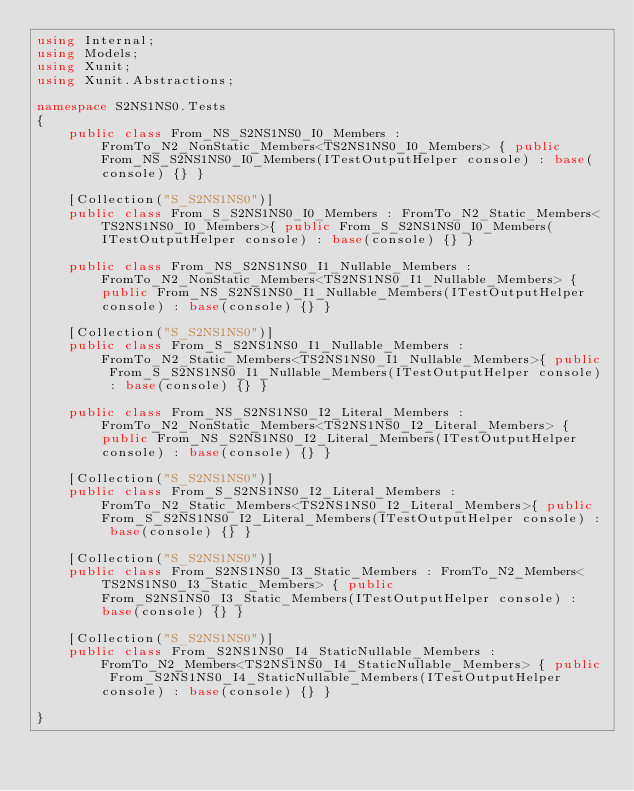<code> <loc_0><loc_0><loc_500><loc_500><_C#_>using Internal;
using Models;
using Xunit;
using Xunit.Abstractions;

namespace S2NS1NS0.Tests
{
	public class From_NS_S2NS1NS0_I0_Members : FromTo_N2_NonStatic_Members<TS2NS1NS0_I0_Members> { public From_NS_S2NS1NS0_I0_Members(ITestOutputHelper console) : base(console) {} }

	[Collection("S_S2NS1NS0")]
	public class From_S_S2NS1NS0_I0_Members : FromTo_N2_Static_Members<TS2NS1NS0_I0_Members>{ public From_S_S2NS1NS0_I0_Members(ITestOutputHelper console) : base(console) {} }

	public class From_NS_S2NS1NS0_I1_Nullable_Members : FromTo_N2_NonStatic_Members<TS2NS1NS0_I1_Nullable_Members> { public From_NS_S2NS1NS0_I1_Nullable_Members(ITestOutputHelper console) : base(console) {} }

	[Collection("S_S2NS1NS0")]
	public class From_S_S2NS1NS0_I1_Nullable_Members : FromTo_N2_Static_Members<TS2NS1NS0_I1_Nullable_Members>{ public From_S_S2NS1NS0_I1_Nullable_Members(ITestOutputHelper console) : base(console) {} }

	public class From_NS_S2NS1NS0_I2_Literal_Members : FromTo_N2_NonStatic_Members<TS2NS1NS0_I2_Literal_Members> { public From_NS_S2NS1NS0_I2_Literal_Members(ITestOutputHelper console) : base(console) {} }

	[Collection("S_S2NS1NS0")]
	public class From_S_S2NS1NS0_I2_Literal_Members : FromTo_N2_Static_Members<TS2NS1NS0_I2_Literal_Members>{ public From_S_S2NS1NS0_I2_Literal_Members(ITestOutputHelper console) : base(console) {} }

	[Collection("S_S2NS1NS0")]
	public class From_S2NS1NS0_I3_Static_Members : FromTo_N2_Members<TS2NS1NS0_I3_Static_Members> { public From_S2NS1NS0_I3_Static_Members(ITestOutputHelper console) : base(console) {} }

	[Collection("S_S2NS1NS0")]
	public class From_S2NS1NS0_I4_StaticNullable_Members : FromTo_N2_Members<TS2NS1NS0_I4_StaticNullable_Members> { public From_S2NS1NS0_I4_StaticNullable_Members(ITestOutputHelper console) : base(console) {} }

}
</code> 